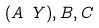Convert formula to latex. <formula><loc_0><loc_0><loc_500><loc_500>( A \ Y ) , B , C</formula> 